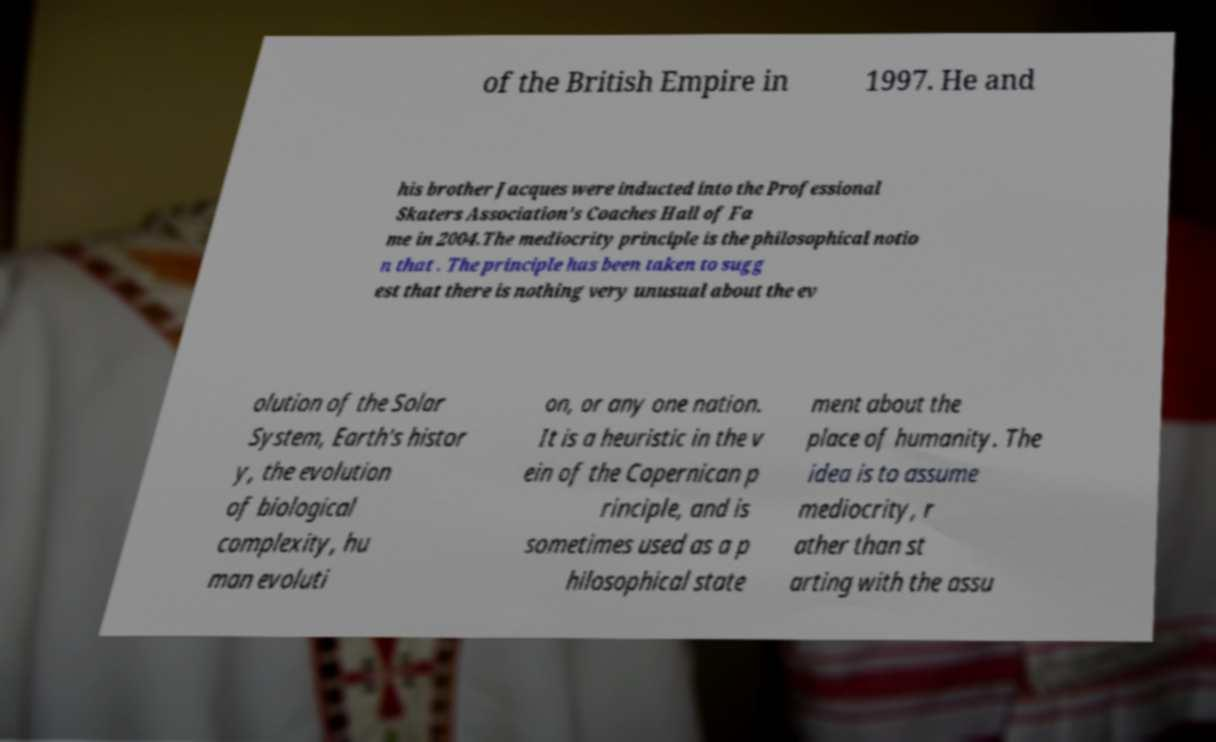Could you extract and type out the text from this image? of the British Empire in 1997. He and his brother Jacques were inducted into the Professional Skaters Association's Coaches Hall of Fa me in 2004.The mediocrity principle is the philosophical notio n that . The principle has been taken to sugg est that there is nothing very unusual about the ev olution of the Solar System, Earth's histor y, the evolution of biological complexity, hu man evoluti on, or any one nation. It is a heuristic in the v ein of the Copernican p rinciple, and is sometimes used as a p hilosophical state ment about the place of humanity. The idea is to assume mediocrity, r ather than st arting with the assu 